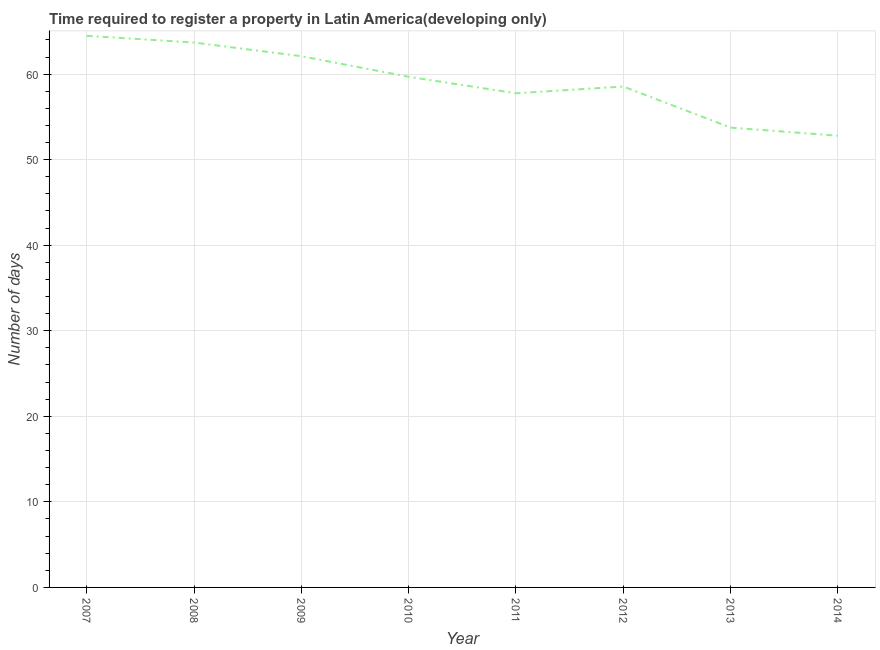What is the number of days required to register property in 2014?
Provide a succinct answer. 52.8. Across all years, what is the maximum number of days required to register property?
Offer a terse response. 64.48. Across all years, what is the minimum number of days required to register property?
Make the answer very short. 52.8. What is the sum of the number of days required to register property?
Keep it short and to the point. 472.81. What is the difference between the number of days required to register property in 2008 and 2011?
Your answer should be compact. 5.93. What is the average number of days required to register property per year?
Make the answer very short. 59.1. What is the median number of days required to register property?
Make the answer very short. 59.12. In how many years, is the number of days required to register property greater than 28 days?
Ensure brevity in your answer.  8. Do a majority of the years between 2010 and 2014 (inclusive) have number of days required to register property greater than 40 days?
Provide a short and direct response. Yes. What is the ratio of the number of days required to register property in 2007 to that in 2010?
Your response must be concise. 1.08. Is the difference between the number of days required to register property in 2009 and 2010 greater than the difference between any two years?
Offer a terse response. No. What is the difference between the highest and the second highest number of days required to register property?
Your response must be concise. 0.79. Is the sum of the number of days required to register property in 2007 and 2010 greater than the maximum number of days required to register property across all years?
Give a very brief answer. Yes. What is the difference between the highest and the lowest number of days required to register property?
Provide a short and direct response. 11.68. How many lines are there?
Your answer should be very brief. 1. What is the difference between two consecutive major ticks on the Y-axis?
Keep it short and to the point. 10. Are the values on the major ticks of Y-axis written in scientific E-notation?
Your answer should be very brief. No. What is the title of the graph?
Provide a succinct answer. Time required to register a property in Latin America(developing only). What is the label or title of the Y-axis?
Your answer should be compact. Number of days. What is the Number of days of 2007?
Provide a short and direct response. 64.48. What is the Number of days in 2008?
Your answer should be compact. 63.69. What is the Number of days in 2009?
Provide a short and direct response. 62.1. What is the Number of days in 2010?
Give a very brief answer. 59.69. What is the Number of days in 2011?
Give a very brief answer. 57.76. What is the Number of days of 2012?
Provide a succinct answer. 58.55. What is the Number of days of 2013?
Ensure brevity in your answer.  53.75. What is the Number of days of 2014?
Your response must be concise. 52.8. What is the difference between the Number of days in 2007 and 2008?
Keep it short and to the point. 0.79. What is the difference between the Number of days in 2007 and 2009?
Provide a succinct answer. 2.38. What is the difference between the Number of days in 2007 and 2010?
Offer a very short reply. 4.79. What is the difference between the Number of days in 2007 and 2011?
Your response must be concise. 6.71. What is the difference between the Number of days in 2007 and 2012?
Your answer should be very brief. 5.93. What is the difference between the Number of days in 2007 and 2013?
Offer a very short reply. 10.73. What is the difference between the Number of days in 2007 and 2014?
Offer a very short reply. 11.68. What is the difference between the Number of days in 2008 and 2009?
Your answer should be compact. 1.6. What is the difference between the Number of days in 2008 and 2011?
Your answer should be very brief. 5.93. What is the difference between the Number of days in 2008 and 2012?
Keep it short and to the point. 5.14. What is the difference between the Number of days in 2008 and 2013?
Your response must be concise. 9.94. What is the difference between the Number of days in 2008 and 2014?
Your answer should be very brief. 10.89. What is the difference between the Number of days in 2009 and 2010?
Offer a very short reply. 2.4. What is the difference between the Number of days in 2009 and 2011?
Give a very brief answer. 4.33. What is the difference between the Number of days in 2009 and 2012?
Your response must be concise. 3.55. What is the difference between the Number of days in 2009 and 2013?
Provide a succinct answer. 8.35. What is the difference between the Number of days in 2009 and 2014?
Keep it short and to the point. 9.3. What is the difference between the Number of days in 2010 and 2011?
Make the answer very short. 1.93. What is the difference between the Number of days in 2010 and 2012?
Your answer should be very brief. 1.14. What is the difference between the Number of days in 2010 and 2013?
Offer a terse response. 5.94. What is the difference between the Number of days in 2010 and 2014?
Ensure brevity in your answer.  6.89. What is the difference between the Number of days in 2011 and 2012?
Your response must be concise. -0.79. What is the difference between the Number of days in 2011 and 2013?
Keep it short and to the point. 4.01. What is the difference between the Number of days in 2011 and 2014?
Offer a terse response. 4.96. What is the difference between the Number of days in 2012 and 2013?
Offer a very short reply. 4.8. What is the difference between the Number of days in 2012 and 2014?
Make the answer very short. 5.75. What is the difference between the Number of days in 2013 and 2014?
Give a very brief answer. 0.95. What is the ratio of the Number of days in 2007 to that in 2008?
Provide a succinct answer. 1.01. What is the ratio of the Number of days in 2007 to that in 2009?
Provide a succinct answer. 1.04. What is the ratio of the Number of days in 2007 to that in 2011?
Ensure brevity in your answer.  1.12. What is the ratio of the Number of days in 2007 to that in 2012?
Your answer should be compact. 1.1. What is the ratio of the Number of days in 2007 to that in 2014?
Provide a succinct answer. 1.22. What is the ratio of the Number of days in 2008 to that in 2010?
Provide a succinct answer. 1.07. What is the ratio of the Number of days in 2008 to that in 2011?
Make the answer very short. 1.1. What is the ratio of the Number of days in 2008 to that in 2012?
Your answer should be compact. 1.09. What is the ratio of the Number of days in 2008 to that in 2013?
Offer a terse response. 1.19. What is the ratio of the Number of days in 2008 to that in 2014?
Make the answer very short. 1.21. What is the ratio of the Number of days in 2009 to that in 2010?
Provide a succinct answer. 1.04. What is the ratio of the Number of days in 2009 to that in 2011?
Keep it short and to the point. 1.07. What is the ratio of the Number of days in 2009 to that in 2012?
Make the answer very short. 1.06. What is the ratio of the Number of days in 2009 to that in 2013?
Provide a short and direct response. 1.16. What is the ratio of the Number of days in 2009 to that in 2014?
Offer a very short reply. 1.18. What is the ratio of the Number of days in 2010 to that in 2011?
Ensure brevity in your answer.  1.03. What is the ratio of the Number of days in 2010 to that in 2012?
Offer a very short reply. 1.02. What is the ratio of the Number of days in 2010 to that in 2013?
Provide a succinct answer. 1.11. What is the ratio of the Number of days in 2010 to that in 2014?
Give a very brief answer. 1.13. What is the ratio of the Number of days in 2011 to that in 2012?
Offer a terse response. 0.99. What is the ratio of the Number of days in 2011 to that in 2013?
Offer a terse response. 1.07. What is the ratio of the Number of days in 2011 to that in 2014?
Keep it short and to the point. 1.09. What is the ratio of the Number of days in 2012 to that in 2013?
Offer a terse response. 1.09. What is the ratio of the Number of days in 2012 to that in 2014?
Your answer should be very brief. 1.11. 